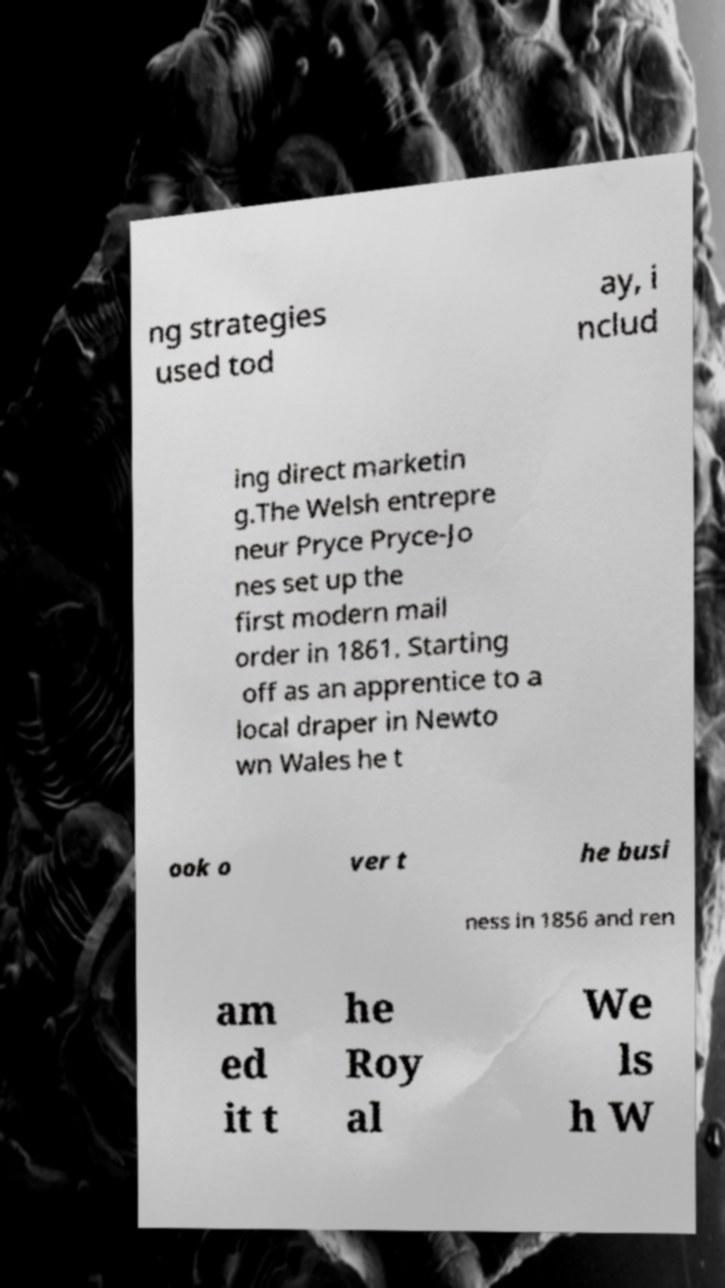Can you accurately transcribe the text from the provided image for me? ng strategies used tod ay, i nclud ing direct marketin g.The Welsh entrepre neur Pryce Pryce-Jo nes set up the first modern mail order in 1861. Starting off as an apprentice to a local draper in Newto wn Wales he t ook o ver t he busi ness in 1856 and ren am ed it t he Roy al We ls h W 